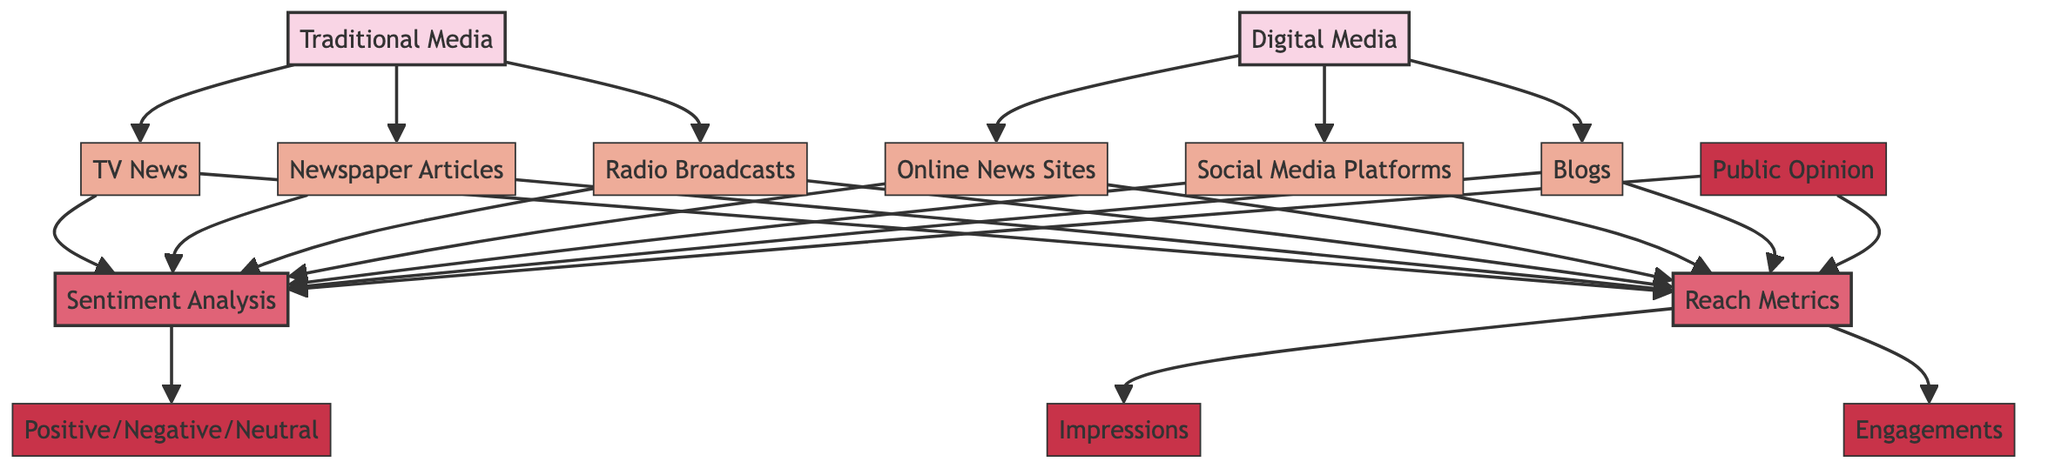What are the two main categories of media coverage in the diagram? The diagram clearly indicates two main categories of media coverage: Traditional Media and Digital Media. These categories are the top-level nodes in the hierarchy of the diagram.
Answer: Traditional Media, Digital Media How many subcategories are listed under Traditional Media? The diagram shows three subcategories under Traditional Media: TV News, Newspaper Articles, and Radio Broadcasts. Counting these subcategories gives a total of three.
Answer: 3 What type of analysis is performed for both media categories? Both categories of media coverage lead to two specific analyses: Sentiment Analysis and Reach Metrics. The diagram illustrates this flow from Traditional and Digital Media to these analyses.
Answer: Sentiment Analysis, Reach Metrics What types of metrics are included in Reach Metrics? The diagram details two specific metrics included in Reach Metrics: Impressions and Engagements. These metrics represent different ways to measure audience reach and interaction with media coverage.
Answer: Impressions, Engagements What sentiment categories are shown in the Sentiment Analysis? In the Sentiment Analysis section of the diagram, three sentiment categories are identified: Positive, Negative, and Neutral. This shows the breakdown of public sentiment regarding the media coverage.
Answer: Positive, Negative, Neutral How does Public Opinion relate to Sentiment Analysis? Public Opinion is a detail node that directly influences Sentiment Analysis according to the diagram. This establishes a relationship where public opinion contributes to understanding sentiment.
Answer: Influences If all media types are considered, how many total paths lead into Sentiment Analysis? The diagram indicates that all media types, both Traditional and Digital, lead to Sentiment Analysis, creating a total of six paths (three from Traditional Media and three from Digital Media).
Answer: 6 In the diagram, which media type has the most subcategories? The diagram shows that both Traditional Media and Digital Media have three subcategories each. Therefore, neither has more subcategories; they are equal in this aspect.
Answer: Equal What is the relationship between Public Opinion and Reach Metrics? The diagram depicts that Public Opinion also leads directly to Reach Metrics. This establishes a direct connection where public opinion impacts the measurement of media reach.
Answer: Direct connection 